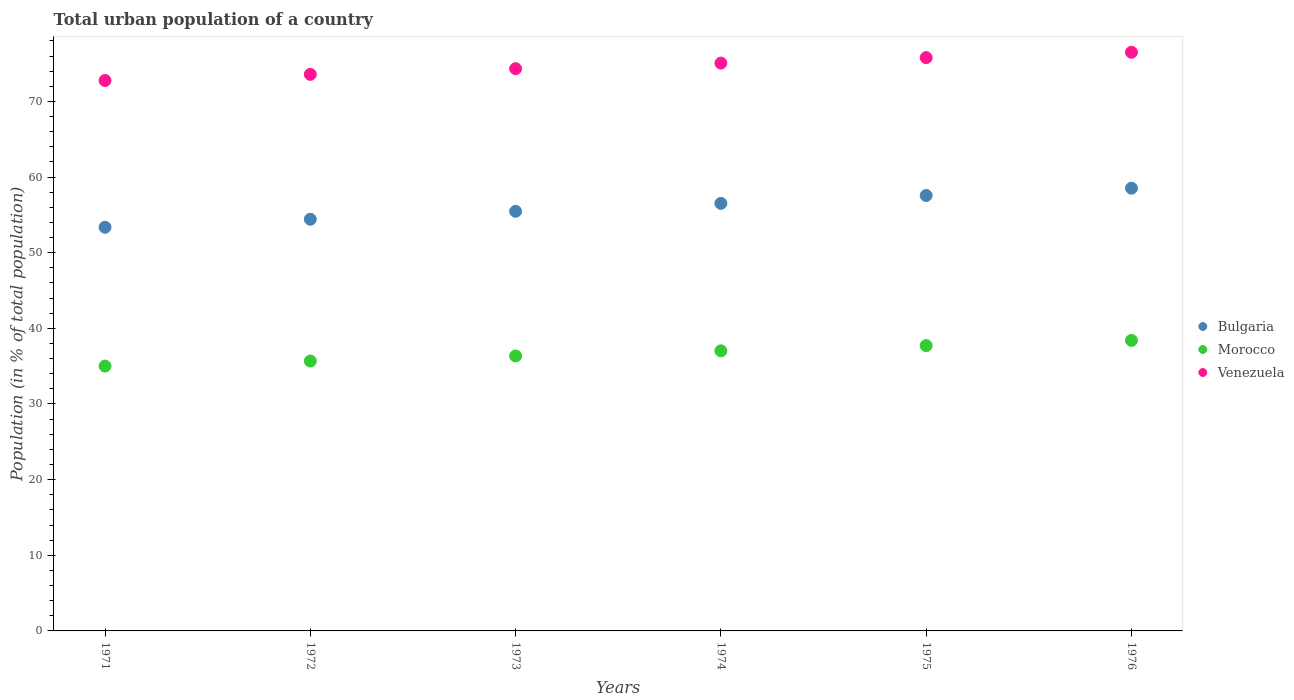How many different coloured dotlines are there?
Provide a succinct answer. 3. Is the number of dotlines equal to the number of legend labels?
Provide a short and direct response. Yes. What is the urban population in Bulgaria in 1974?
Your response must be concise. 56.52. Across all years, what is the maximum urban population in Morocco?
Your response must be concise. 38.41. Across all years, what is the minimum urban population in Bulgaria?
Give a very brief answer. 53.36. In which year was the urban population in Morocco maximum?
Keep it short and to the point. 1976. In which year was the urban population in Bulgaria minimum?
Make the answer very short. 1971. What is the total urban population in Bulgaria in the graph?
Offer a very short reply. 335.86. What is the difference between the urban population in Bulgaria in 1974 and that in 1975?
Your response must be concise. -1.04. What is the difference between the urban population in Bulgaria in 1973 and the urban population in Venezuela in 1975?
Your response must be concise. -20.32. What is the average urban population in Morocco per year?
Provide a succinct answer. 36.7. In the year 1975, what is the difference between the urban population in Morocco and urban population in Venezuela?
Your answer should be very brief. -38.07. In how many years, is the urban population in Venezuela greater than 60 %?
Give a very brief answer. 6. What is the ratio of the urban population in Venezuela in 1972 to that in 1975?
Offer a very short reply. 0.97. Is the urban population in Bulgaria in 1974 less than that in 1975?
Offer a very short reply. Yes. What is the difference between the highest and the second highest urban population in Bulgaria?
Keep it short and to the point. 0.96. What is the difference between the highest and the lowest urban population in Morocco?
Your answer should be compact. 3.39. In how many years, is the urban population in Venezuela greater than the average urban population in Venezuela taken over all years?
Your response must be concise. 3. Is the sum of the urban population in Bulgaria in 1971 and 1976 greater than the maximum urban population in Venezuela across all years?
Offer a terse response. Yes. How many dotlines are there?
Your response must be concise. 3. Are the values on the major ticks of Y-axis written in scientific E-notation?
Give a very brief answer. No. Does the graph contain grids?
Your answer should be compact. No. How are the legend labels stacked?
Offer a very short reply. Vertical. What is the title of the graph?
Ensure brevity in your answer.  Total urban population of a country. Does "Micronesia" appear as one of the legend labels in the graph?
Keep it short and to the point. No. What is the label or title of the X-axis?
Your answer should be very brief. Years. What is the label or title of the Y-axis?
Ensure brevity in your answer.  Population (in % of total population). What is the Population (in % of total population) of Bulgaria in 1971?
Ensure brevity in your answer.  53.36. What is the Population (in % of total population) of Morocco in 1971?
Provide a succinct answer. 35.01. What is the Population (in % of total population) in Venezuela in 1971?
Offer a very short reply. 72.76. What is the Population (in % of total population) in Bulgaria in 1972?
Ensure brevity in your answer.  54.42. What is the Population (in % of total population) of Morocco in 1972?
Keep it short and to the point. 35.67. What is the Population (in % of total population) of Venezuela in 1972?
Make the answer very short. 73.58. What is the Population (in % of total population) of Bulgaria in 1973?
Make the answer very short. 55.47. What is the Population (in % of total population) of Morocco in 1973?
Give a very brief answer. 36.35. What is the Population (in % of total population) in Venezuela in 1973?
Make the answer very short. 74.33. What is the Population (in % of total population) of Bulgaria in 1974?
Offer a very short reply. 56.52. What is the Population (in % of total population) of Morocco in 1974?
Ensure brevity in your answer.  37.03. What is the Population (in % of total population) in Venezuela in 1974?
Provide a succinct answer. 75.06. What is the Population (in % of total population) in Bulgaria in 1975?
Offer a very short reply. 57.56. What is the Population (in % of total population) of Morocco in 1975?
Your answer should be very brief. 37.71. What is the Population (in % of total population) of Venezuela in 1975?
Your response must be concise. 75.79. What is the Population (in % of total population) of Bulgaria in 1976?
Your answer should be very brief. 58.53. What is the Population (in % of total population) in Morocco in 1976?
Your answer should be very brief. 38.41. What is the Population (in % of total population) in Venezuela in 1976?
Provide a short and direct response. 76.5. Across all years, what is the maximum Population (in % of total population) of Bulgaria?
Provide a short and direct response. 58.53. Across all years, what is the maximum Population (in % of total population) of Morocco?
Offer a terse response. 38.41. Across all years, what is the maximum Population (in % of total population) of Venezuela?
Provide a short and direct response. 76.5. Across all years, what is the minimum Population (in % of total population) of Bulgaria?
Your response must be concise. 53.36. Across all years, what is the minimum Population (in % of total population) of Morocco?
Your answer should be compact. 35.01. Across all years, what is the minimum Population (in % of total population) in Venezuela?
Your answer should be very brief. 72.76. What is the total Population (in % of total population) of Bulgaria in the graph?
Offer a very short reply. 335.86. What is the total Population (in % of total population) in Morocco in the graph?
Offer a terse response. 220.18. What is the total Population (in % of total population) in Venezuela in the graph?
Your response must be concise. 448.01. What is the difference between the Population (in % of total population) in Bulgaria in 1971 and that in 1972?
Your response must be concise. -1.06. What is the difference between the Population (in % of total population) of Morocco in 1971 and that in 1972?
Make the answer very short. -0.66. What is the difference between the Population (in % of total population) of Venezuela in 1971 and that in 1972?
Provide a short and direct response. -0.81. What is the difference between the Population (in % of total population) in Bulgaria in 1971 and that in 1973?
Provide a succinct answer. -2.11. What is the difference between the Population (in % of total population) of Morocco in 1971 and that in 1973?
Give a very brief answer. -1.34. What is the difference between the Population (in % of total population) of Venezuela in 1971 and that in 1973?
Offer a terse response. -1.56. What is the difference between the Population (in % of total population) in Bulgaria in 1971 and that in 1974?
Your answer should be very brief. -3.16. What is the difference between the Population (in % of total population) in Morocco in 1971 and that in 1974?
Keep it short and to the point. -2.02. What is the difference between the Population (in % of total population) in Venezuela in 1971 and that in 1974?
Your answer should be very brief. -2.3. What is the difference between the Population (in % of total population) in Bulgaria in 1971 and that in 1975?
Ensure brevity in your answer.  -4.2. What is the difference between the Population (in % of total population) of Morocco in 1971 and that in 1975?
Ensure brevity in your answer.  -2.7. What is the difference between the Population (in % of total population) of Venezuela in 1971 and that in 1975?
Offer a terse response. -3.02. What is the difference between the Population (in % of total population) in Bulgaria in 1971 and that in 1976?
Provide a short and direct response. -5.17. What is the difference between the Population (in % of total population) of Morocco in 1971 and that in 1976?
Give a very brief answer. -3.39. What is the difference between the Population (in % of total population) in Venezuela in 1971 and that in 1976?
Your response must be concise. -3.73. What is the difference between the Population (in % of total population) in Bulgaria in 1972 and that in 1973?
Provide a short and direct response. -1.05. What is the difference between the Population (in % of total population) in Morocco in 1972 and that in 1973?
Keep it short and to the point. -0.67. What is the difference between the Population (in % of total population) of Venezuela in 1972 and that in 1973?
Offer a very short reply. -0.75. What is the difference between the Population (in % of total population) of Bulgaria in 1972 and that in 1974?
Ensure brevity in your answer.  -2.1. What is the difference between the Population (in % of total population) in Morocco in 1972 and that in 1974?
Your response must be concise. -1.35. What is the difference between the Population (in % of total population) of Venezuela in 1972 and that in 1974?
Your answer should be compact. -1.49. What is the difference between the Population (in % of total population) in Bulgaria in 1972 and that in 1975?
Keep it short and to the point. -3.14. What is the difference between the Population (in % of total population) of Morocco in 1972 and that in 1975?
Ensure brevity in your answer.  -2.04. What is the difference between the Population (in % of total population) of Venezuela in 1972 and that in 1975?
Make the answer very short. -2.21. What is the difference between the Population (in % of total population) of Bulgaria in 1972 and that in 1976?
Offer a very short reply. -4.11. What is the difference between the Population (in % of total population) in Morocco in 1972 and that in 1976?
Make the answer very short. -2.73. What is the difference between the Population (in % of total population) in Venezuela in 1972 and that in 1976?
Keep it short and to the point. -2.92. What is the difference between the Population (in % of total population) in Bulgaria in 1973 and that in 1974?
Ensure brevity in your answer.  -1.05. What is the difference between the Population (in % of total population) in Morocco in 1973 and that in 1974?
Your answer should be compact. -0.68. What is the difference between the Population (in % of total population) in Venezuela in 1973 and that in 1974?
Your answer should be compact. -0.74. What is the difference between the Population (in % of total population) in Bulgaria in 1973 and that in 1975?
Offer a terse response. -2.09. What is the difference between the Population (in % of total population) in Morocco in 1973 and that in 1975?
Make the answer very short. -1.36. What is the difference between the Population (in % of total population) in Venezuela in 1973 and that in 1975?
Provide a succinct answer. -1.46. What is the difference between the Population (in % of total population) of Bulgaria in 1973 and that in 1976?
Your answer should be very brief. -3.06. What is the difference between the Population (in % of total population) in Morocco in 1973 and that in 1976?
Your answer should be compact. -2.06. What is the difference between the Population (in % of total population) of Venezuela in 1973 and that in 1976?
Make the answer very short. -2.17. What is the difference between the Population (in % of total population) of Bulgaria in 1974 and that in 1975?
Provide a succinct answer. -1.04. What is the difference between the Population (in % of total population) in Morocco in 1974 and that in 1975?
Your response must be concise. -0.69. What is the difference between the Population (in % of total population) in Venezuela in 1974 and that in 1975?
Provide a short and direct response. -0.72. What is the difference between the Population (in % of total population) in Bulgaria in 1974 and that in 1976?
Ensure brevity in your answer.  -2.01. What is the difference between the Population (in % of total population) of Morocco in 1974 and that in 1976?
Provide a short and direct response. -1.38. What is the difference between the Population (in % of total population) of Venezuela in 1974 and that in 1976?
Your answer should be compact. -1.43. What is the difference between the Population (in % of total population) of Bulgaria in 1975 and that in 1976?
Keep it short and to the point. -0.96. What is the difference between the Population (in % of total population) in Morocco in 1975 and that in 1976?
Your answer should be compact. -0.69. What is the difference between the Population (in % of total population) in Venezuela in 1975 and that in 1976?
Make the answer very short. -0.71. What is the difference between the Population (in % of total population) in Bulgaria in 1971 and the Population (in % of total population) in Morocco in 1972?
Provide a succinct answer. 17.68. What is the difference between the Population (in % of total population) in Bulgaria in 1971 and the Population (in % of total population) in Venezuela in 1972?
Your response must be concise. -20.21. What is the difference between the Population (in % of total population) of Morocco in 1971 and the Population (in % of total population) of Venezuela in 1972?
Your response must be concise. -38.56. What is the difference between the Population (in % of total population) of Bulgaria in 1971 and the Population (in % of total population) of Morocco in 1973?
Provide a succinct answer. 17.01. What is the difference between the Population (in % of total population) of Bulgaria in 1971 and the Population (in % of total population) of Venezuela in 1973?
Your answer should be compact. -20.96. What is the difference between the Population (in % of total population) of Morocco in 1971 and the Population (in % of total population) of Venezuela in 1973?
Provide a succinct answer. -39.31. What is the difference between the Population (in % of total population) of Bulgaria in 1971 and the Population (in % of total population) of Morocco in 1974?
Ensure brevity in your answer.  16.33. What is the difference between the Population (in % of total population) of Bulgaria in 1971 and the Population (in % of total population) of Venezuela in 1974?
Give a very brief answer. -21.7. What is the difference between the Population (in % of total population) in Morocco in 1971 and the Population (in % of total population) in Venezuela in 1974?
Offer a very short reply. -40.05. What is the difference between the Population (in % of total population) of Bulgaria in 1971 and the Population (in % of total population) of Morocco in 1975?
Ensure brevity in your answer.  15.65. What is the difference between the Population (in % of total population) of Bulgaria in 1971 and the Population (in % of total population) of Venezuela in 1975?
Your answer should be very brief. -22.43. What is the difference between the Population (in % of total population) in Morocco in 1971 and the Population (in % of total population) in Venezuela in 1975?
Give a very brief answer. -40.77. What is the difference between the Population (in % of total population) in Bulgaria in 1971 and the Population (in % of total population) in Morocco in 1976?
Provide a short and direct response. 14.96. What is the difference between the Population (in % of total population) in Bulgaria in 1971 and the Population (in % of total population) in Venezuela in 1976?
Ensure brevity in your answer.  -23.14. What is the difference between the Population (in % of total population) in Morocco in 1971 and the Population (in % of total population) in Venezuela in 1976?
Provide a succinct answer. -41.48. What is the difference between the Population (in % of total population) in Bulgaria in 1972 and the Population (in % of total population) in Morocco in 1973?
Offer a terse response. 18.07. What is the difference between the Population (in % of total population) in Bulgaria in 1972 and the Population (in % of total population) in Venezuela in 1973?
Give a very brief answer. -19.91. What is the difference between the Population (in % of total population) of Morocco in 1972 and the Population (in % of total population) of Venezuela in 1973?
Provide a succinct answer. -38.65. What is the difference between the Population (in % of total population) of Bulgaria in 1972 and the Population (in % of total population) of Morocco in 1974?
Give a very brief answer. 17.39. What is the difference between the Population (in % of total population) in Bulgaria in 1972 and the Population (in % of total population) in Venezuela in 1974?
Your response must be concise. -20.64. What is the difference between the Population (in % of total population) of Morocco in 1972 and the Population (in % of total population) of Venezuela in 1974?
Give a very brief answer. -39.39. What is the difference between the Population (in % of total population) of Bulgaria in 1972 and the Population (in % of total population) of Morocco in 1975?
Your answer should be compact. 16.7. What is the difference between the Population (in % of total population) in Bulgaria in 1972 and the Population (in % of total population) in Venezuela in 1975?
Provide a succinct answer. -21.37. What is the difference between the Population (in % of total population) of Morocco in 1972 and the Population (in % of total population) of Venezuela in 1975?
Provide a succinct answer. -40.11. What is the difference between the Population (in % of total population) in Bulgaria in 1972 and the Population (in % of total population) in Morocco in 1976?
Your response must be concise. 16.01. What is the difference between the Population (in % of total population) in Bulgaria in 1972 and the Population (in % of total population) in Venezuela in 1976?
Offer a terse response. -22.08. What is the difference between the Population (in % of total population) in Morocco in 1972 and the Population (in % of total population) in Venezuela in 1976?
Your answer should be compact. -40.82. What is the difference between the Population (in % of total population) in Bulgaria in 1973 and the Population (in % of total population) in Morocco in 1974?
Offer a terse response. 18.44. What is the difference between the Population (in % of total population) of Bulgaria in 1973 and the Population (in % of total population) of Venezuela in 1974?
Ensure brevity in your answer.  -19.59. What is the difference between the Population (in % of total population) of Morocco in 1973 and the Population (in % of total population) of Venezuela in 1974?
Offer a terse response. -38.71. What is the difference between the Population (in % of total population) in Bulgaria in 1973 and the Population (in % of total population) in Morocco in 1975?
Your answer should be very brief. 17.76. What is the difference between the Population (in % of total population) in Bulgaria in 1973 and the Population (in % of total population) in Venezuela in 1975?
Keep it short and to the point. -20.32. What is the difference between the Population (in % of total population) of Morocco in 1973 and the Population (in % of total population) of Venezuela in 1975?
Your answer should be very brief. -39.44. What is the difference between the Population (in % of total population) in Bulgaria in 1973 and the Population (in % of total population) in Morocco in 1976?
Offer a very short reply. 17.07. What is the difference between the Population (in % of total population) of Bulgaria in 1973 and the Population (in % of total population) of Venezuela in 1976?
Offer a very short reply. -21.02. What is the difference between the Population (in % of total population) of Morocco in 1973 and the Population (in % of total population) of Venezuela in 1976?
Your response must be concise. -40.15. What is the difference between the Population (in % of total population) in Bulgaria in 1974 and the Population (in % of total population) in Morocco in 1975?
Ensure brevity in your answer.  18.8. What is the difference between the Population (in % of total population) in Bulgaria in 1974 and the Population (in % of total population) in Venezuela in 1975?
Your answer should be compact. -19.27. What is the difference between the Population (in % of total population) of Morocco in 1974 and the Population (in % of total population) of Venezuela in 1975?
Keep it short and to the point. -38.76. What is the difference between the Population (in % of total population) in Bulgaria in 1974 and the Population (in % of total population) in Morocco in 1976?
Offer a terse response. 18.11. What is the difference between the Population (in % of total population) in Bulgaria in 1974 and the Population (in % of total population) in Venezuela in 1976?
Ensure brevity in your answer.  -19.98. What is the difference between the Population (in % of total population) of Morocco in 1974 and the Population (in % of total population) of Venezuela in 1976?
Offer a very short reply. -39.47. What is the difference between the Population (in % of total population) of Bulgaria in 1975 and the Population (in % of total population) of Morocco in 1976?
Your response must be concise. 19.16. What is the difference between the Population (in % of total population) in Bulgaria in 1975 and the Population (in % of total population) in Venezuela in 1976?
Your answer should be very brief. -18.93. What is the difference between the Population (in % of total population) of Morocco in 1975 and the Population (in % of total population) of Venezuela in 1976?
Ensure brevity in your answer.  -38.78. What is the average Population (in % of total population) in Bulgaria per year?
Give a very brief answer. 55.98. What is the average Population (in % of total population) in Morocco per year?
Ensure brevity in your answer.  36.7. What is the average Population (in % of total population) of Venezuela per year?
Provide a succinct answer. 74.67. In the year 1971, what is the difference between the Population (in % of total population) in Bulgaria and Population (in % of total population) in Morocco?
Your answer should be very brief. 18.35. In the year 1971, what is the difference between the Population (in % of total population) of Bulgaria and Population (in % of total population) of Venezuela?
Your response must be concise. -19.4. In the year 1971, what is the difference between the Population (in % of total population) in Morocco and Population (in % of total population) in Venezuela?
Give a very brief answer. -37.75. In the year 1972, what is the difference between the Population (in % of total population) in Bulgaria and Population (in % of total population) in Morocco?
Make the answer very short. 18.74. In the year 1972, what is the difference between the Population (in % of total population) of Bulgaria and Population (in % of total population) of Venezuela?
Your response must be concise. -19.16. In the year 1972, what is the difference between the Population (in % of total population) of Morocco and Population (in % of total population) of Venezuela?
Keep it short and to the point. -37.9. In the year 1973, what is the difference between the Population (in % of total population) of Bulgaria and Population (in % of total population) of Morocco?
Make the answer very short. 19.12. In the year 1973, what is the difference between the Population (in % of total population) in Bulgaria and Population (in % of total population) in Venezuela?
Make the answer very short. -18.85. In the year 1973, what is the difference between the Population (in % of total population) in Morocco and Population (in % of total population) in Venezuela?
Give a very brief answer. -37.98. In the year 1974, what is the difference between the Population (in % of total population) in Bulgaria and Population (in % of total population) in Morocco?
Offer a terse response. 19.49. In the year 1974, what is the difference between the Population (in % of total population) of Bulgaria and Population (in % of total population) of Venezuela?
Your answer should be compact. -18.54. In the year 1974, what is the difference between the Population (in % of total population) of Morocco and Population (in % of total population) of Venezuela?
Provide a short and direct response. -38.03. In the year 1975, what is the difference between the Population (in % of total population) of Bulgaria and Population (in % of total population) of Morocco?
Keep it short and to the point. 19.85. In the year 1975, what is the difference between the Population (in % of total population) in Bulgaria and Population (in % of total population) in Venezuela?
Your answer should be very brief. -18.22. In the year 1975, what is the difference between the Population (in % of total population) of Morocco and Population (in % of total population) of Venezuela?
Offer a terse response. -38.07. In the year 1976, what is the difference between the Population (in % of total population) of Bulgaria and Population (in % of total population) of Morocco?
Keep it short and to the point. 20.12. In the year 1976, what is the difference between the Population (in % of total population) in Bulgaria and Population (in % of total population) in Venezuela?
Give a very brief answer. -17.97. In the year 1976, what is the difference between the Population (in % of total population) in Morocco and Population (in % of total population) in Venezuela?
Make the answer very short. -38.09. What is the ratio of the Population (in % of total population) of Bulgaria in 1971 to that in 1972?
Your response must be concise. 0.98. What is the ratio of the Population (in % of total population) in Morocco in 1971 to that in 1972?
Provide a succinct answer. 0.98. What is the ratio of the Population (in % of total population) of Bulgaria in 1971 to that in 1973?
Provide a short and direct response. 0.96. What is the ratio of the Population (in % of total population) in Morocco in 1971 to that in 1973?
Your response must be concise. 0.96. What is the ratio of the Population (in % of total population) of Venezuela in 1971 to that in 1973?
Offer a very short reply. 0.98. What is the ratio of the Population (in % of total population) in Bulgaria in 1971 to that in 1974?
Keep it short and to the point. 0.94. What is the ratio of the Population (in % of total population) of Morocco in 1971 to that in 1974?
Your answer should be compact. 0.95. What is the ratio of the Population (in % of total population) of Venezuela in 1971 to that in 1974?
Make the answer very short. 0.97. What is the ratio of the Population (in % of total population) of Bulgaria in 1971 to that in 1975?
Provide a short and direct response. 0.93. What is the ratio of the Population (in % of total population) of Morocco in 1971 to that in 1975?
Ensure brevity in your answer.  0.93. What is the ratio of the Population (in % of total population) in Venezuela in 1971 to that in 1975?
Provide a short and direct response. 0.96. What is the ratio of the Population (in % of total population) in Bulgaria in 1971 to that in 1976?
Make the answer very short. 0.91. What is the ratio of the Population (in % of total population) of Morocco in 1971 to that in 1976?
Make the answer very short. 0.91. What is the ratio of the Population (in % of total population) in Venezuela in 1971 to that in 1976?
Your response must be concise. 0.95. What is the ratio of the Population (in % of total population) in Morocco in 1972 to that in 1973?
Make the answer very short. 0.98. What is the ratio of the Population (in % of total population) in Venezuela in 1972 to that in 1973?
Offer a terse response. 0.99. What is the ratio of the Population (in % of total population) of Bulgaria in 1972 to that in 1974?
Provide a succinct answer. 0.96. What is the ratio of the Population (in % of total population) in Morocco in 1972 to that in 1974?
Your answer should be very brief. 0.96. What is the ratio of the Population (in % of total population) in Venezuela in 1972 to that in 1974?
Your response must be concise. 0.98. What is the ratio of the Population (in % of total population) of Bulgaria in 1972 to that in 1975?
Offer a very short reply. 0.95. What is the ratio of the Population (in % of total population) of Morocco in 1972 to that in 1975?
Keep it short and to the point. 0.95. What is the ratio of the Population (in % of total population) of Venezuela in 1972 to that in 1975?
Your response must be concise. 0.97. What is the ratio of the Population (in % of total population) in Bulgaria in 1972 to that in 1976?
Ensure brevity in your answer.  0.93. What is the ratio of the Population (in % of total population) in Morocco in 1972 to that in 1976?
Your answer should be very brief. 0.93. What is the ratio of the Population (in % of total population) of Venezuela in 1972 to that in 1976?
Your answer should be very brief. 0.96. What is the ratio of the Population (in % of total population) of Bulgaria in 1973 to that in 1974?
Make the answer very short. 0.98. What is the ratio of the Population (in % of total population) in Morocco in 1973 to that in 1974?
Your answer should be very brief. 0.98. What is the ratio of the Population (in % of total population) in Venezuela in 1973 to that in 1974?
Your answer should be very brief. 0.99. What is the ratio of the Population (in % of total population) of Bulgaria in 1973 to that in 1975?
Give a very brief answer. 0.96. What is the ratio of the Population (in % of total population) of Morocco in 1973 to that in 1975?
Your response must be concise. 0.96. What is the ratio of the Population (in % of total population) in Venezuela in 1973 to that in 1975?
Keep it short and to the point. 0.98. What is the ratio of the Population (in % of total population) of Bulgaria in 1973 to that in 1976?
Keep it short and to the point. 0.95. What is the ratio of the Population (in % of total population) in Morocco in 1973 to that in 1976?
Your response must be concise. 0.95. What is the ratio of the Population (in % of total population) in Venezuela in 1973 to that in 1976?
Provide a succinct answer. 0.97. What is the ratio of the Population (in % of total population) of Bulgaria in 1974 to that in 1975?
Provide a short and direct response. 0.98. What is the ratio of the Population (in % of total population) in Morocco in 1974 to that in 1975?
Provide a succinct answer. 0.98. What is the ratio of the Population (in % of total population) of Venezuela in 1974 to that in 1975?
Give a very brief answer. 0.99. What is the ratio of the Population (in % of total population) of Bulgaria in 1974 to that in 1976?
Your answer should be compact. 0.97. What is the ratio of the Population (in % of total population) in Morocco in 1974 to that in 1976?
Your response must be concise. 0.96. What is the ratio of the Population (in % of total population) in Venezuela in 1974 to that in 1976?
Provide a succinct answer. 0.98. What is the ratio of the Population (in % of total population) of Bulgaria in 1975 to that in 1976?
Provide a short and direct response. 0.98. What is the ratio of the Population (in % of total population) of Morocco in 1975 to that in 1976?
Make the answer very short. 0.98. What is the ratio of the Population (in % of total population) of Venezuela in 1975 to that in 1976?
Offer a terse response. 0.99. What is the difference between the highest and the second highest Population (in % of total population) in Morocco?
Provide a short and direct response. 0.69. What is the difference between the highest and the second highest Population (in % of total population) of Venezuela?
Keep it short and to the point. 0.71. What is the difference between the highest and the lowest Population (in % of total population) in Bulgaria?
Make the answer very short. 5.17. What is the difference between the highest and the lowest Population (in % of total population) in Morocco?
Offer a terse response. 3.39. What is the difference between the highest and the lowest Population (in % of total population) of Venezuela?
Give a very brief answer. 3.73. 